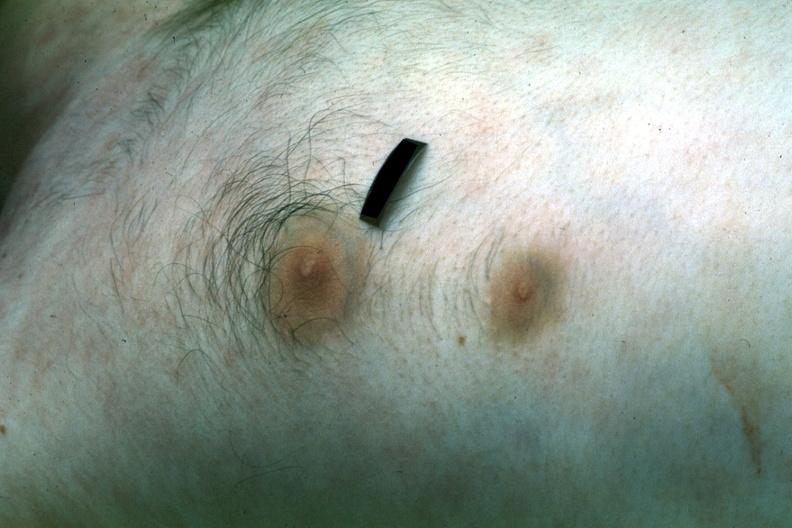does this image show two nipples?
Answer the question using a single word or phrase. Yes 